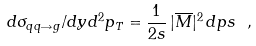<formula> <loc_0><loc_0><loc_500><loc_500>d \sigma _ { q q \rightarrow g } / d y d ^ { 2 } p _ { T } = \frac { 1 } { 2 s } \, | \overline { M } | ^ { 2 } \, d p s \ ,</formula> 